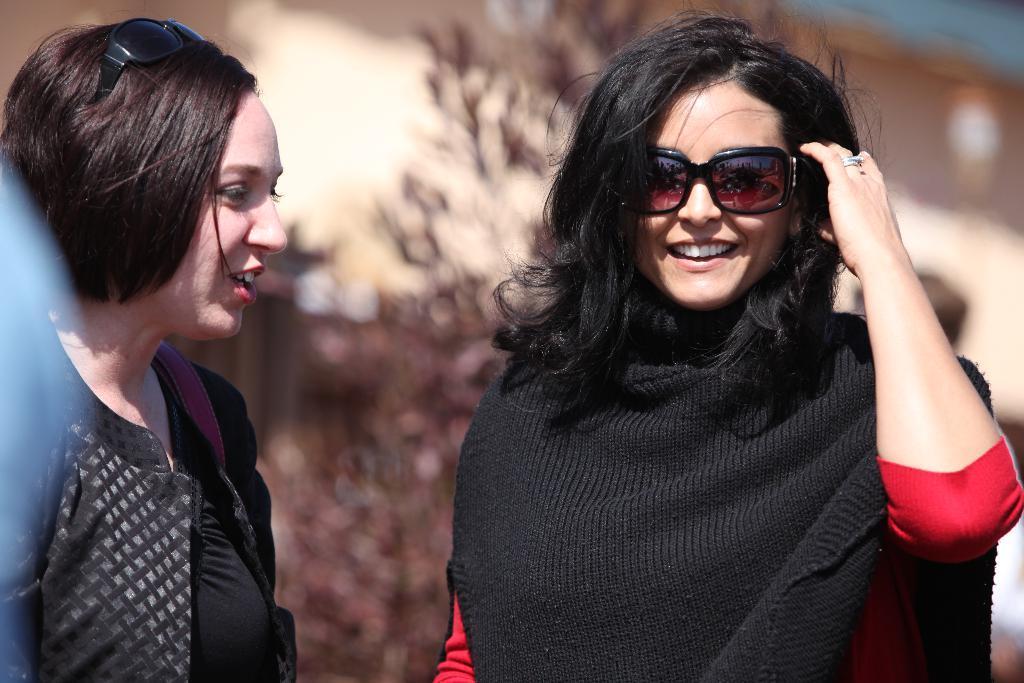Could you give a brief overview of what you see in this image? In the foreground of this image, there are two women. One is wearing black jacket and another is wearing black sweater and the background image is blurred. 